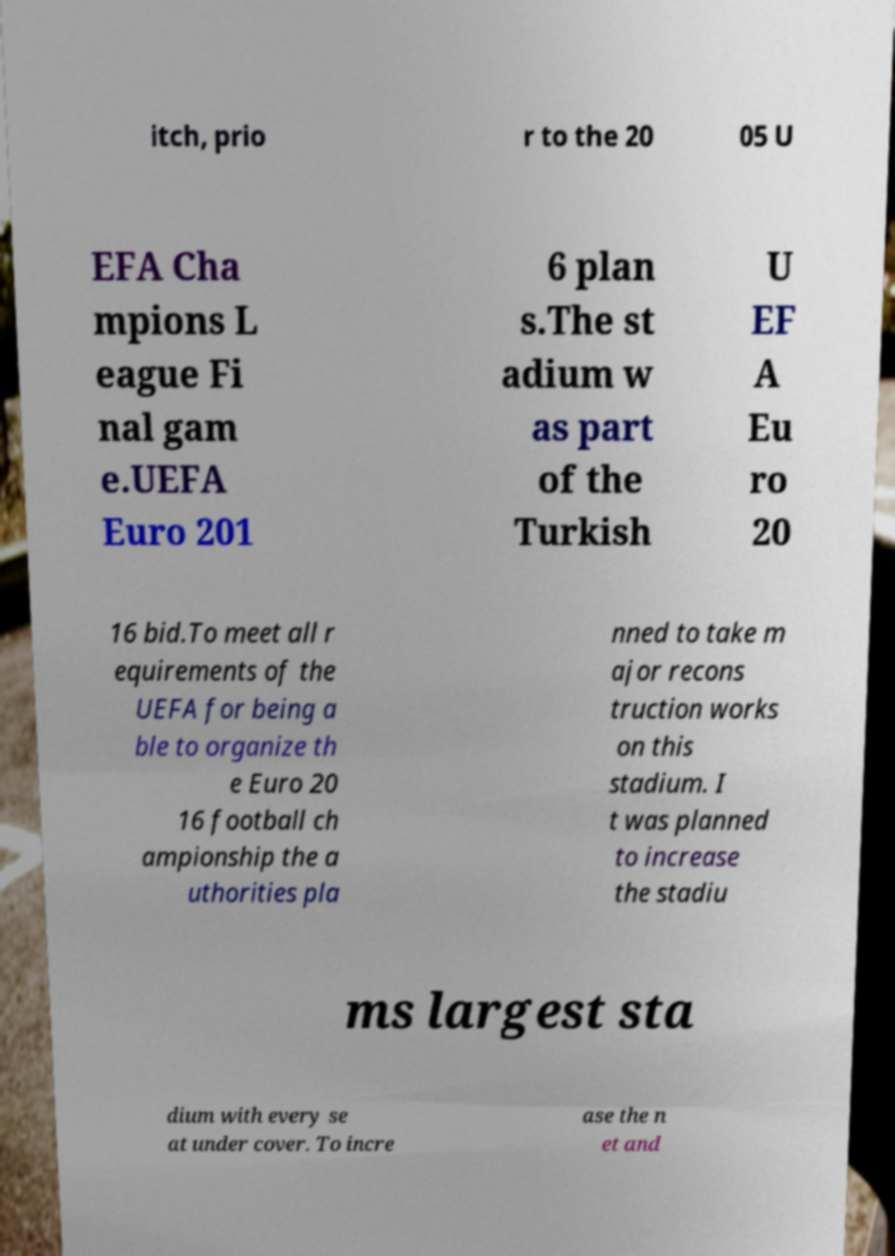What messages or text are displayed in this image? I need them in a readable, typed format. itch, prio r to the 20 05 U EFA Cha mpions L eague Fi nal gam e.UEFA Euro 201 6 plan s.The st adium w as part of the Turkish U EF A Eu ro 20 16 bid.To meet all r equirements of the UEFA for being a ble to organize th e Euro 20 16 football ch ampionship the a uthorities pla nned to take m ajor recons truction works on this stadium. I t was planned to increase the stadiu ms largest sta dium with every se at under cover. To incre ase the n et and 